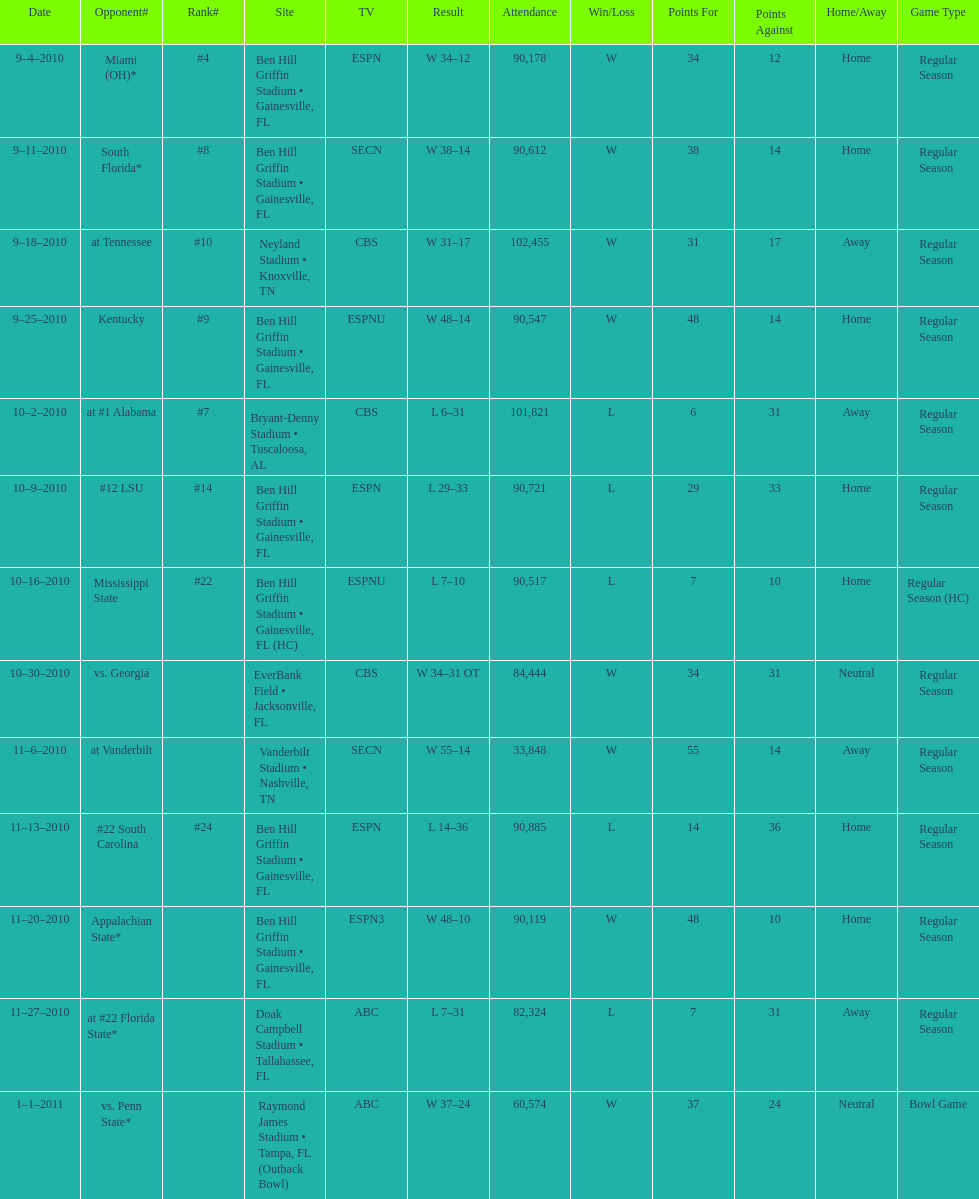What was the difference between the two scores of the last game? 13 points. Can you parse all the data within this table? {'header': ['Date', 'Opponent#', 'Rank#', 'Site', 'TV', 'Result', 'Attendance', 'Win/Loss', 'Points For', 'Points Against', 'Home/Away', 'Game Type'], 'rows': [['9–4–2010', 'Miami (OH)*', '#4', 'Ben Hill Griffin Stadium • Gainesville, FL', 'ESPN', 'W\xa034–12', '90,178', 'W', '34', '12', 'Home', 'Regular Season'], ['9–11–2010', 'South Florida*', '#8', 'Ben Hill Griffin Stadium • Gainesville, FL', 'SECN', 'W\xa038–14', '90,612', 'W', '38', '14', 'Home', 'Regular Season'], ['9–18–2010', 'at\xa0Tennessee', '#10', 'Neyland Stadium • Knoxville, TN', 'CBS', 'W\xa031–17', '102,455', 'W', '31', '17', 'Away', 'Regular Season'], ['9–25–2010', 'Kentucky', '#9', 'Ben Hill Griffin Stadium • Gainesville, FL', 'ESPNU', 'W\xa048–14', '90,547', 'W', '48', '14', 'Home', 'Regular Season'], ['10–2–2010', 'at\xa0#1\xa0Alabama', '#7', 'Bryant-Denny Stadium • Tuscaloosa, AL', 'CBS', 'L\xa06–31', '101,821', 'L', '6', '31', 'Away', 'Regular Season'], ['10–9–2010', '#12\xa0LSU', '#14', 'Ben Hill Griffin Stadium • Gainesville, FL', 'ESPN', 'L\xa029–33', '90,721', 'L', '29', '33', 'Home', 'Regular Season'], ['10–16–2010', 'Mississippi State', '#22', 'Ben Hill Griffin Stadium • Gainesville, FL (HC)', 'ESPNU', 'L\xa07–10', '90,517', 'L', '7', '10', 'Home', 'Regular Season (HC)'], ['10–30–2010', 'vs.\xa0Georgia', '', 'EverBank Field • Jacksonville, FL', 'CBS', 'W\xa034–31\xa0OT', '84,444', 'W', '34', '31', 'Neutral', 'Regular Season'], ['11–6–2010', 'at\xa0Vanderbilt', '', 'Vanderbilt Stadium • Nashville, TN', 'SECN', 'W\xa055–14', '33,848', 'W', '55', '14', 'Away', 'Regular Season'], ['11–13–2010', '#22\xa0South Carolina', '#24', 'Ben Hill Griffin Stadium • Gainesville, FL', 'ESPN', 'L\xa014–36', '90,885', 'L', '14', '36', 'Home', 'Regular Season'], ['11–20–2010', 'Appalachian State*', '', 'Ben Hill Griffin Stadium • Gainesville, FL', 'ESPN3', 'W\xa048–10', '90,119', 'W', '48', '10', 'Home', 'Regular Season'], ['11–27–2010', 'at\xa0#22\xa0Florida State*', '', 'Doak Campbell Stadium • Tallahassee, FL', 'ABC', 'L\xa07–31', '82,324', 'L', '7', '31', 'Away', 'Regular Season'], ['1–1–2011', 'vs.\xa0Penn State*', '', 'Raymond James Stadium • Tampa, FL (Outback Bowl)', 'ABC', 'W\xa037–24', '60,574', 'W', '37', '24', 'Neutral', 'Bowl Game']]} 